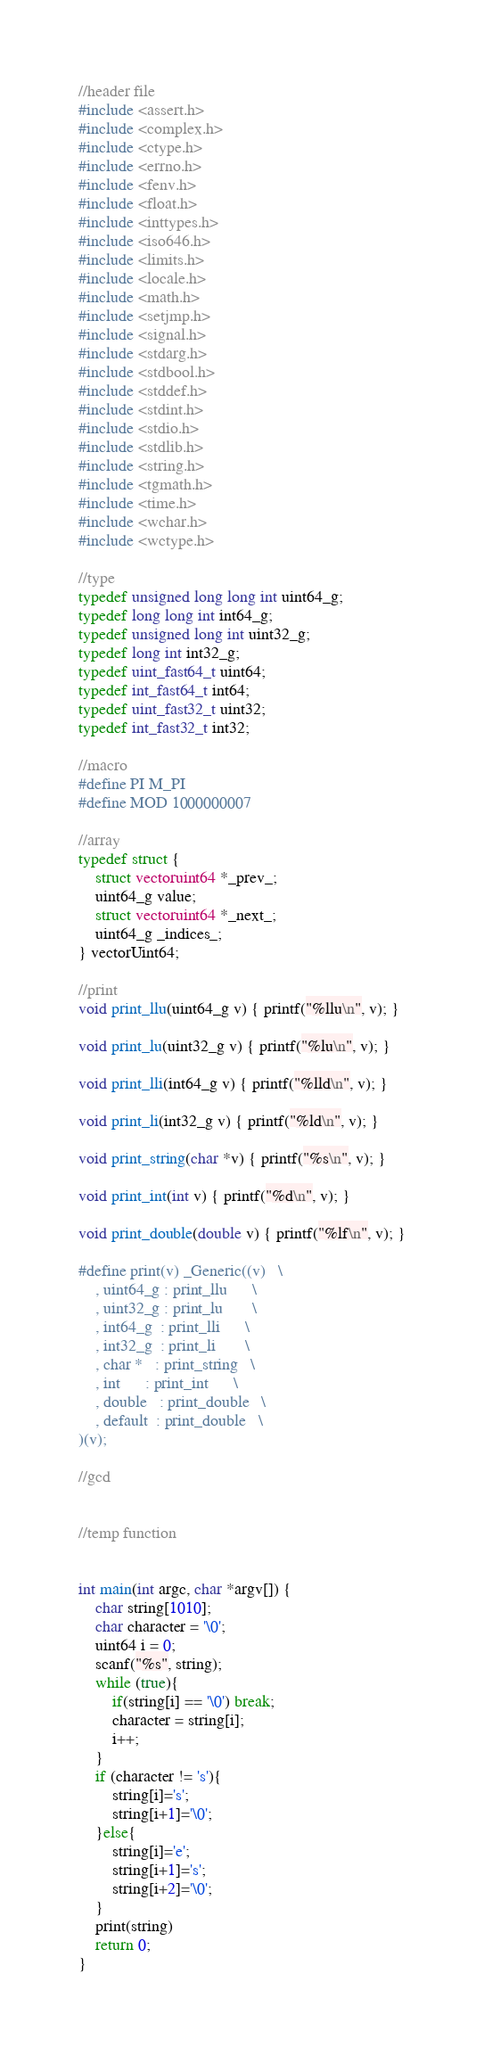Convert code to text. <code><loc_0><loc_0><loc_500><loc_500><_C_>//header file
#include <assert.h>
#include <complex.h>
#include <ctype.h>
#include <errno.h>
#include <fenv.h>
#include <float.h>
#include <inttypes.h>
#include <iso646.h>
#include <limits.h>
#include <locale.h>
#include <math.h>
#include <setjmp.h>
#include <signal.h>
#include <stdarg.h>
#include <stdbool.h>
#include <stddef.h>
#include <stdint.h>
#include <stdio.h>
#include <stdlib.h>
#include <string.h>
#include <tgmath.h>
#include <time.h>
#include <wchar.h>
#include <wctype.h>

//type
typedef unsigned long long int uint64_g;
typedef long long int int64_g;
typedef unsigned long int uint32_g;
typedef long int int32_g;
typedef uint_fast64_t uint64;
typedef int_fast64_t int64;
typedef uint_fast32_t uint32;
typedef int_fast32_t int32;

//macro
#define PI M_PI
#define MOD 1000000007

//array
typedef struct {
    struct vectoruint64 *_prev_;
    uint64_g value;
    struct vectoruint64 *_next_;
    uint64_g _indices_;
} vectorUint64;

//print
void print_llu(uint64_g v) { printf("%llu\n", v); }

void print_lu(uint32_g v) { printf("%lu\n", v); }

void print_lli(int64_g v) { printf("%lld\n", v); }

void print_li(int32_g v) { printf("%ld\n", v); }

void print_string(char *v) { printf("%s\n", v); }

void print_int(int v) { printf("%d\n", v); }

void print_double(double v) { printf("%lf\n", v); }

#define print(v) _Generic((v)   \
    , uint64_g : print_llu      \
    , uint32_g : print_lu       \
    , int64_g  : print_lli      \
    , int32_g  : print_li       \
    , char *   : print_string   \
    , int      : print_int      \
    , double   : print_double   \
    , default  : print_double   \
)(v);

//gcd


//temp function


int main(int argc, char *argv[]) {
    char string[1010];
    char character = '\0';
    uint64 i = 0;
    scanf("%s", string);
    while (true){
        if(string[i] == '\0') break;
        character = string[i];
        i++;
    }
    if (character != 's'){
        string[i]='s';
        string[i+1]='\0';
    }else{
        string[i]='e';
        string[i+1]='s';
        string[i+2]='\0';
    }
    print(string)
    return 0;
}</code> 